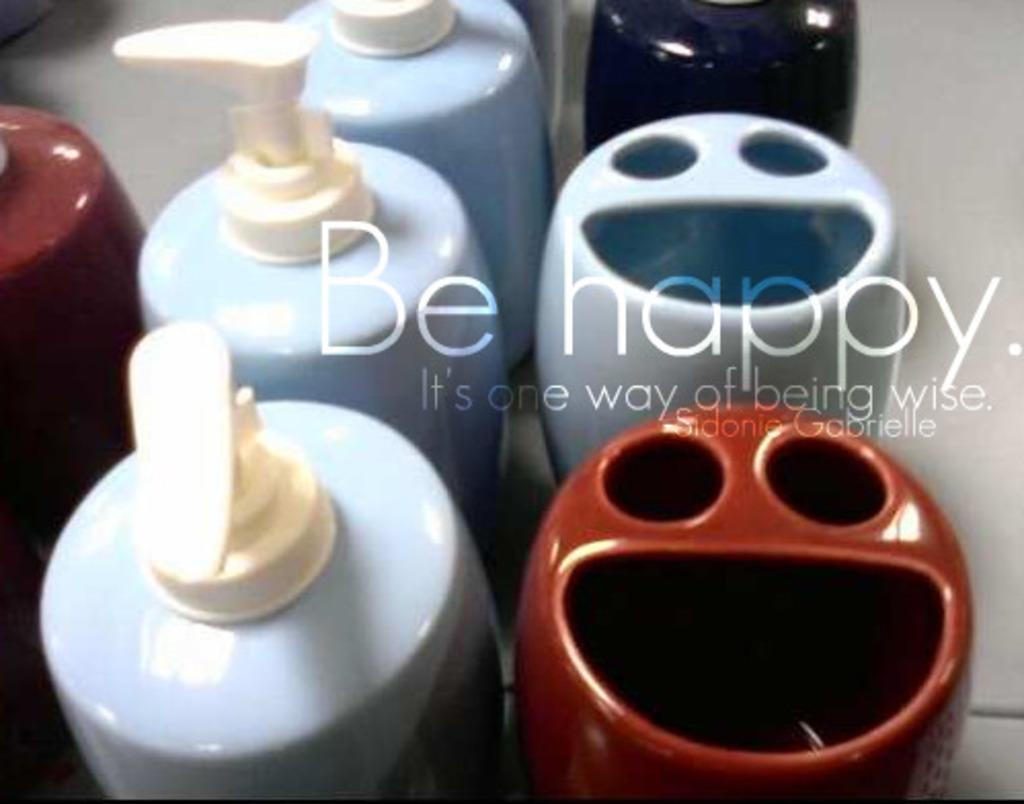How would you summarize this image in a sentence or two? In this picture we can see there are bottles and some objects. On the image there is a watermark. 